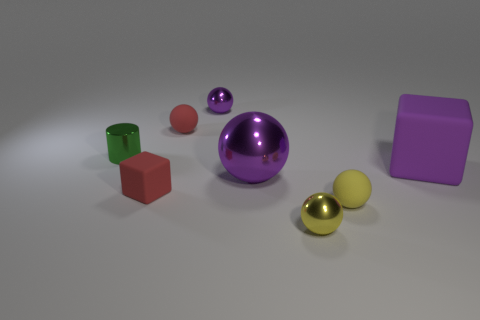Subtract all small yellow rubber spheres. How many spheres are left? 4 Subtract 2 balls. How many balls are left? 3 Add 1 yellow spheres. How many objects exist? 9 Subtract all red cubes. How many cubes are left? 1 Subtract all red spheres. How many green cubes are left? 0 Add 5 tiny matte cubes. How many tiny matte cubes exist? 6 Subtract 0 yellow cylinders. How many objects are left? 8 Subtract all cylinders. How many objects are left? 7 Subtract all brown cubes. Subtract all purple balls. How many cubes are left? 2 Subtract all large red shiny cylinders. Subtract all metal cylinders. How many objects are left? 7 